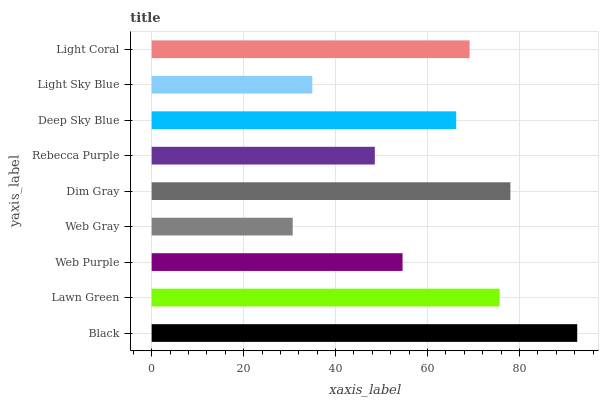Is Web Gray the minimum?
Answer yes or no. Yes. Is Black the maximum?
Answer yes or no. Yes. Is Lawn Green the minimum?
Answer yes or no. No. Is Lawn Green the maximum?
Answer yes or no. No. Is Black greater than Lawn Green?
Answer yes or no. Yes. Is Lawn Green less than Black?
Answer yes or no. Yes. Is Lawn Green greater than Black?
Answer yes or no. No. Is Black less than Lawn Green?
Answer yes or no. No. Is Deep Sky Blue the high median?
Answer yes or no. Yes. Is Deep Sky Blue the low median?
Answer yes or no. Yes. Is Lawn Green the high median?
Answer yes or no. No. Is Light Coral the low median?
Answer yes or no. No. 